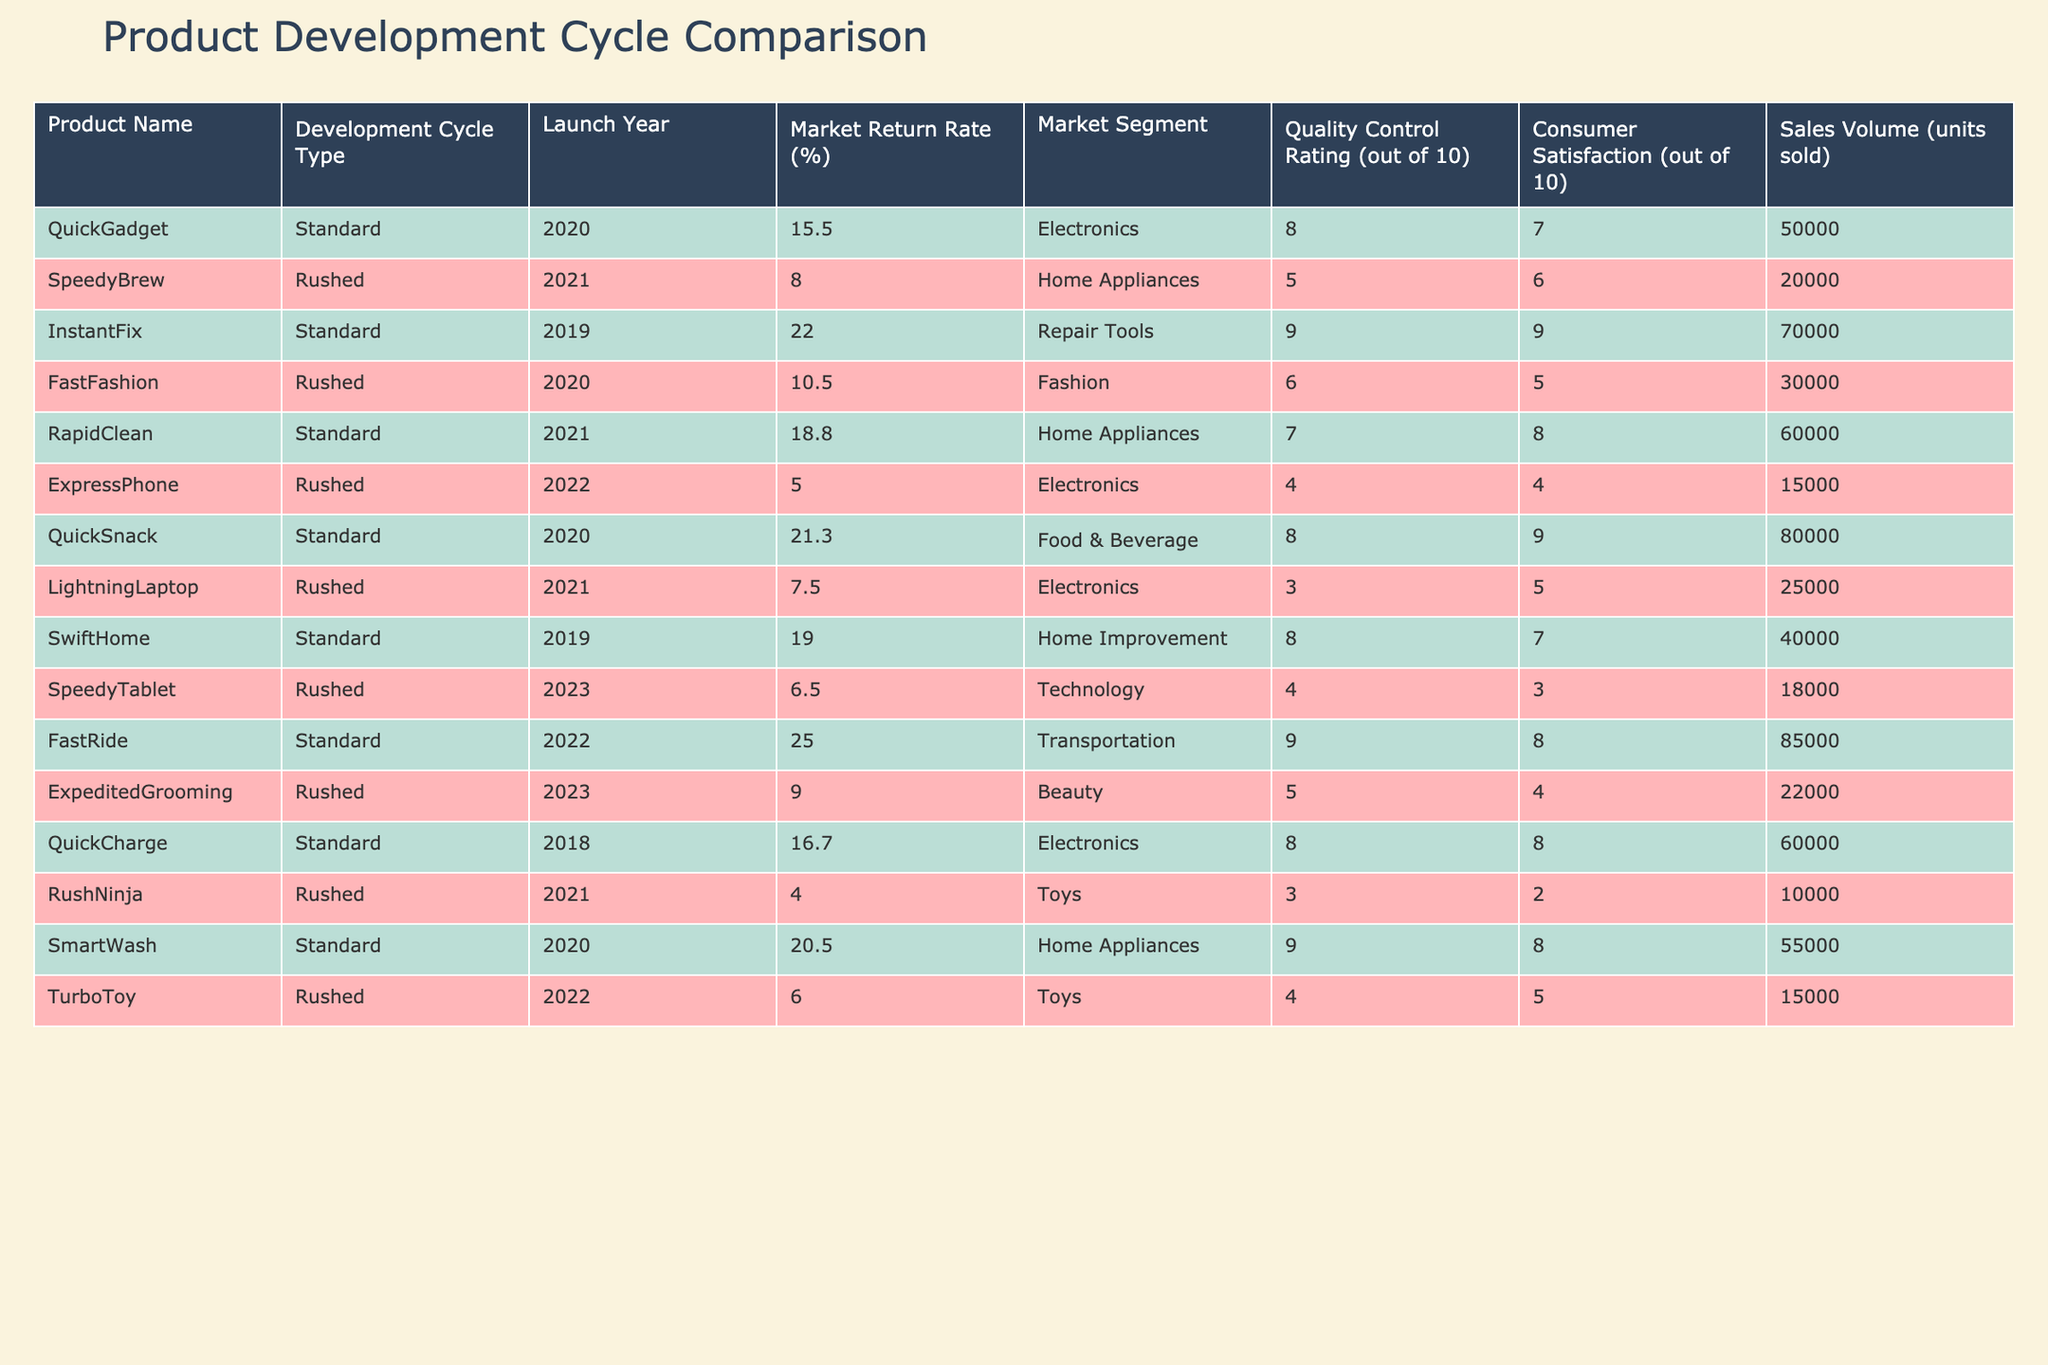What is the market return rate for the product "SpeedyBrew"? The market return rate for "SpeedyBrew," which was rushed to market in 2021, is 8.0%.
Answer: 8.0% What is the quality control rating for "QuickSnack"? The quality control rating for "QuickSnack," which has a standard development cycle, is 8 out of 10.
Answer: 8 Which product with a rushed development cycle has the highest market return rate? The product with the highest market return rate in the rushed category is "FastFashion," with a rate of 10.5%.
Answer: 10.5% What is the average market return rate for standard development cycle products? The market return rates for standard development cycle products are 15.5, 22.0, 18.8, 21.3, 19.0, 25.0, and 16.7, totaling 138.3. There are 7 products, so the average is 138.3 / 7 = 19.74%.
Answer: 19.74% How does the consumer satisfaction for "ExpressPhone" compare to "QuickCharge"? "ExpressPhone" has a consumer satisfaction rating of 4, while "QuickCharge" has a rating of 8. The difference is 8 - 4 = 4 points in favor of "QuickCharge".
Answer: 4 points Is the market return rate for the "TurboToy" higher than the average for rushed products? The market return rate for "TurboToy" is 6.0%. The average market return rate for the rushed products is (8.0 + 10.5 + 5.0 + 7.5 + 6.5 + 9.0 + 4.0 + 6.0) = 56.5 / 8 = 7.06%. Since 6.0% is less than 7.06%, the answer is no.
Answer: No What is the correlation between the market return rate and consumer satisfaction for rushed products? The market return rates for the rushed products are 8.0, 10.5, 5.0, 7.5, 6.5, 9.0, 4.0, and 6.0, with consumer satisfaction ratings of 6, 5, 4, 5, 3, 4, 2, and 5, respectively. By analyzing these ratings, the correlation appears to be negative, indicating lower return rates may be linked to lower satisfaction.
Answer: Negative correlation What is the total sales volume for standard products? The sales volumes of standard products are 50000, 70000, 60000, 80000, 40000, 85000, and 60000, totaling 50000 + 70000 + 60000 + 80000 + 40000 + 85000 + 60000 = 455000.
Answer: 455000 units What percentage of products rushed to market exceeded a market return rate of 6%? The rushed products with return rates above 6% are "SpeedyBrew" (8.0), "FastFashion" (10.5), and "ExpeditedGrooming" (9.0). Out of 8 rushed products, 3 exceed 6%, giving a percentage of (3/8) * 100 = 37.5%.
Answer: 37.5% Which product with the highest quality control rating has the highest market return rate? "InstantFix" has the highest quality control rating of 9 and a market return rate of 22.0%. Other products do not exceed this return rate with the same or higher quality rating.
Answer: InstantFix 